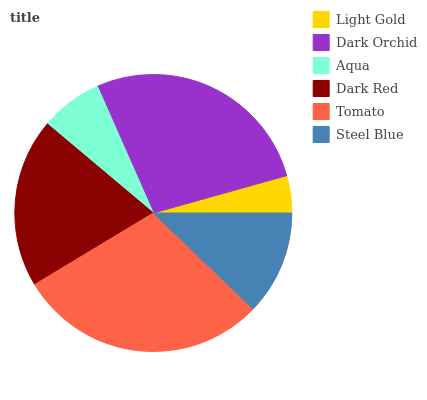Is Light Gold the minimum?
Answer yes or no. Yes. Is Tomato the maximum?
Answer yes or no. Yes. Is Dark Orchid the minimum?
Answer yes or no. No. Is Dark Orchid the maximum?
Answer yes or no. No. Is Dark Orchid greater than Light Gold?
Answer yes or no. Yes. Is Light Gold less than Dark Orchid?
Answer yes or no. Yes. Is Light Gold greater than Dark Orchid?
Answer yes or no. No. Is Dark Orchid less than Light Gold?
Answer yes or no. No. Is Dark Red the high median?
Answer yes or no. Yes. Is Steel Blue the low median?
Answer yes or no. Yes. Is Light Gold the high median?
Answer yes or no. No. Is Dark Orchid the low median?
Answer yes or no. No. 